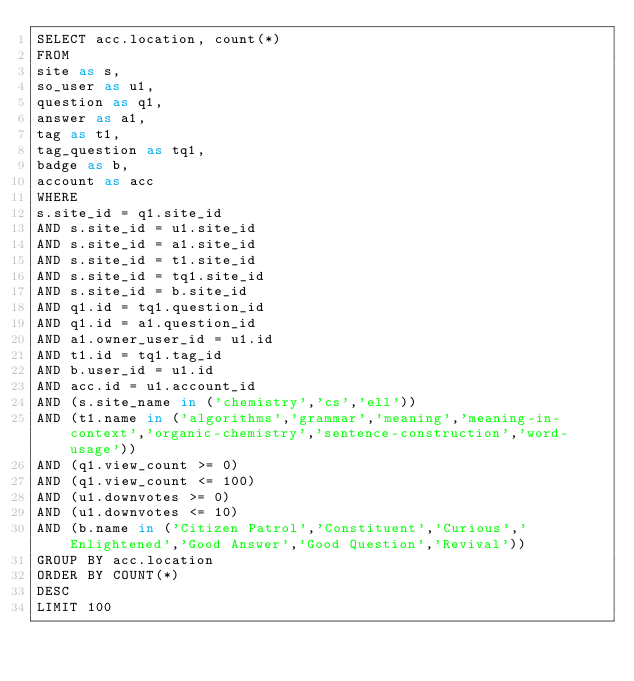<code> <loc_0><loc_0><loc_500><loc_500><_SQL_>SELECT acc.location, count(*)
FROM
site as s,
so_user as u1,
question as q1,
answer as a1,
tag as t1,
tag_question as tq1,
badge as b,
account as acc
WHERE
s.site_id = q1.site_id
AND s.site_id = u1.site_id
AND s.site_id = a1.site_id
AND s.site_id = t1.site_id
AND s.site_id = tq1.site_id
AND s.site_id = b.site_id
AND q1.id = tq1.question_id
AND q1.id = a1.question_id
AND a1.owner_user_id = u1.id
AND t1.id = tq1.tag_id
AND b.user_id = u1.id
AND acc.id = u1.account_id
AND (s.site_name in ('chemistry','cs','ell'))
AND (t1.name in ('algorithms','grammar','meaning','meaning-in-context','organic-chemistry','sentence-construction','word-usage'))
AND (q1.view_count >= 0)
AND (q1.view_count <= 100)
AND (u1.downvotes >= 0)
AND (u1.downvotes <= 10)
AND (b.name in ('Citizen Patrol','Constituent','Curious','Enlightened','Good Answer','Good Question','Revival'))
GROUP BY acc.location
ORDER BY COUNT(*)
DESC
LIMIT 100
</code> 